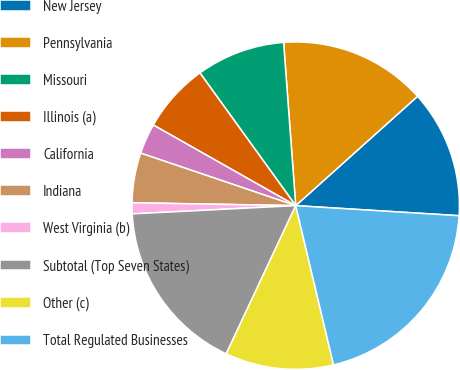Convert chart to OTSL. <chart><loc_0><loc_0><loc_500><loc_500><pie_chart><fcel>New Jersey<fcel>Pennsylvania<fcel>Missouri<fcel>Illinois (a)<fcel>California<fcel>Indiana<fcel>West Virginia (b)<fcel>Subtotal (Top Seven States)<fcel>Other (c)<fcel>Total Regulated Businesses<nl><fcel>12.62%<fcel>14.54%<fcel>8.77%<fcel>6.85%<fcel>3.0%<fcel>4.92%<fcel>1.08%<fcel>17.22%<fcel>10.69%<fcel>20.31%<nl></chart> 